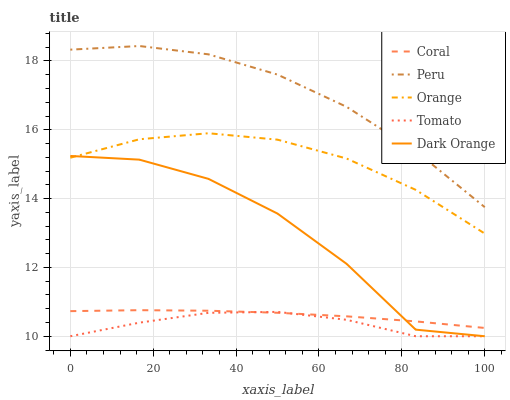Does Tomato have the minimum area under the curve?
Answer yes or no. Yes. Does Peru have the maximum area under the curve?
Answer yes or no. Yes. Does Coral have the minimum area under the curve?
Answer yes or no. No. Does Coral have the maximum area under the curve?
Answer yes or no. No. Is Coral the smoothest?
Answer yes or no. Yes. Is Dark Orange the roughest?
Answer yes or no. Yes. Is Tomato the smoothest?
Answer yes or no. No. Is Tomato the roughest?
Answer yes or no. No. Does Tomato have the lowest value?
Answer yes or no. Yes. Does Coral have the lowest value?
Answer yes or no. No. Does Peru have the highest value?
Answer yes or no. Yes. Does Coral have the highest value?
Answer yes or no. No. Is Orange less than Peru?
Answer yes or no. Yes. Is Orange greater than Coral?
Answer yes or no. Yes. Does Tomato intersect Coral?
Answer yes or no. Yes. Is Tomato less than Coral?
Answer yes or no. No. Is Tomato greater than Coral?
Answer yes or no. No. Does Orange intersect Peru?
Answer yes or no. No. 